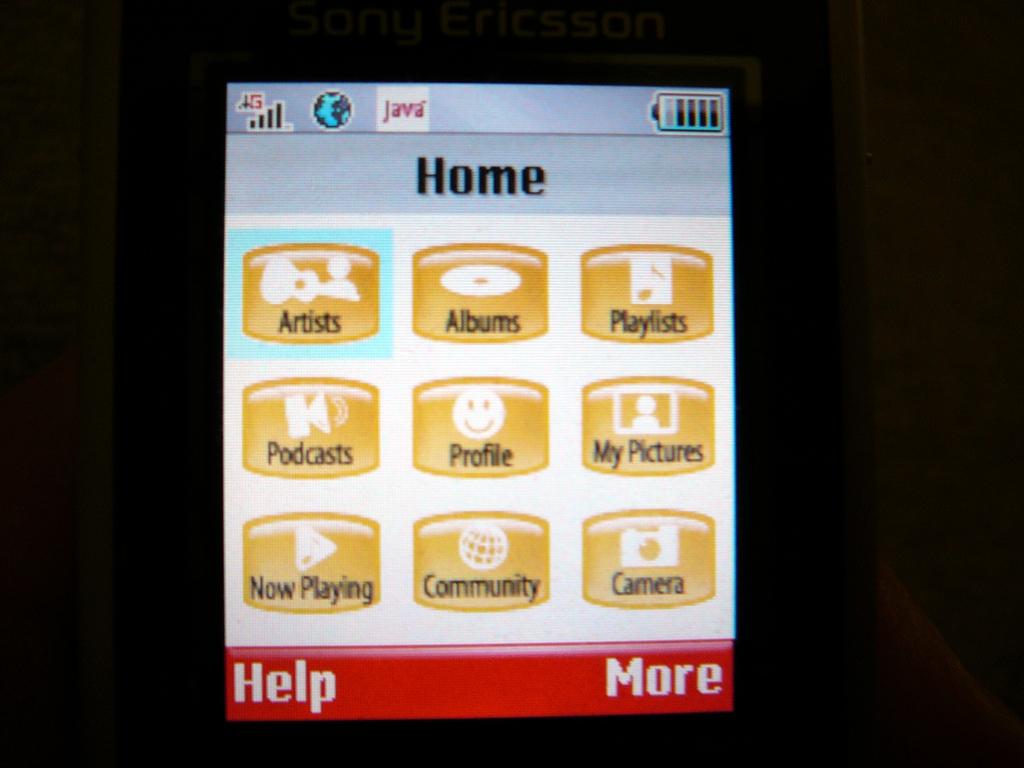What is written on the bottom left?
Make the answer very short. Help. 